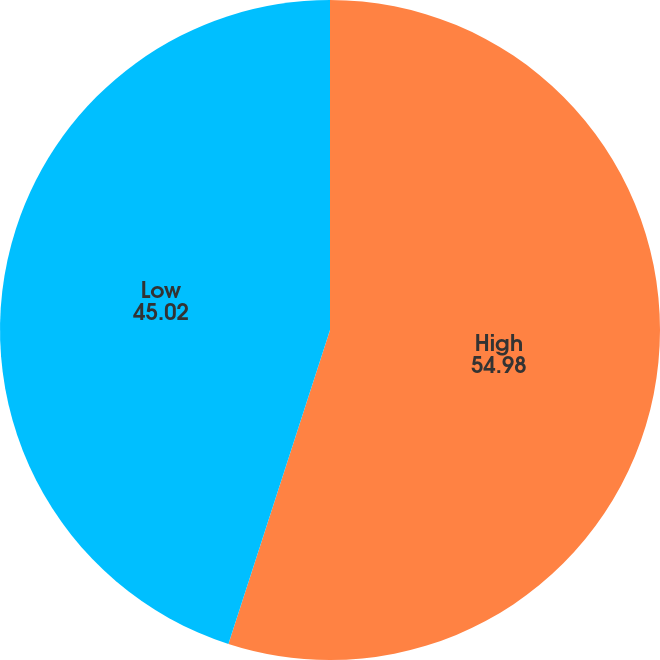Convert chart to OTSL. <chart><loc_0><loc_0><loc_500><loc_500><pie_chart><fcel>High<fcel>Low<nl><fcel>54.98%<fcel>45.02%<nl></chart> 